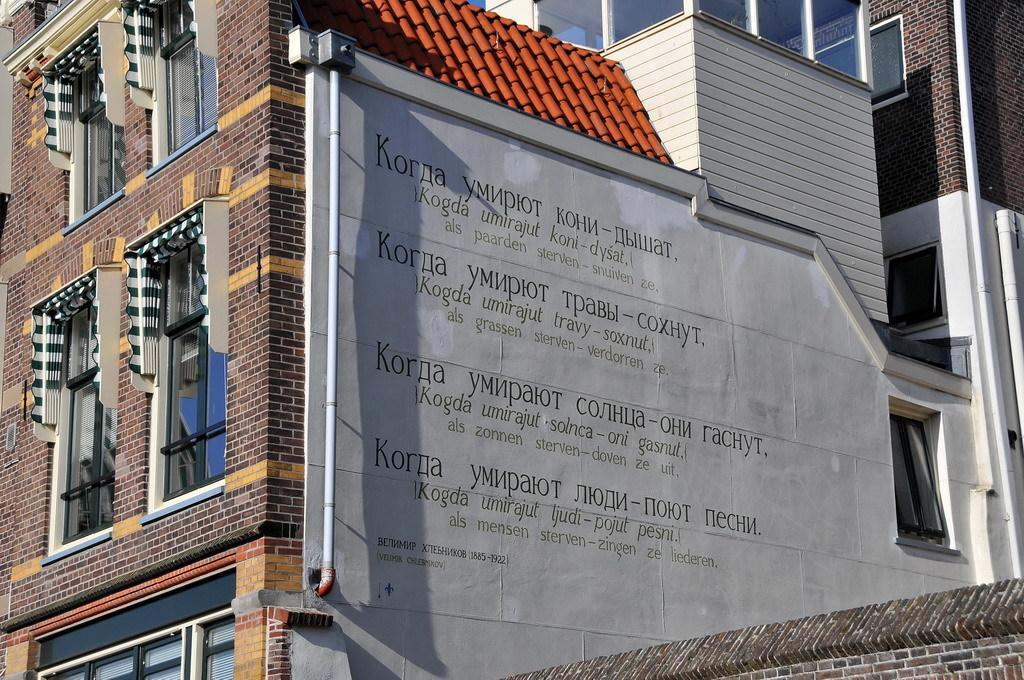What type of structure is present in the image? There is a building in the image. What feature can be seen on the building? The building has windows. What additional object is visible in the image? There is a pipe in the image. What color is the rooftop of the building? The rooftop of the building is red. Can you see a tiger walking on the rooftop of the building in the image? No, there is no tiger or any animal visible in the image. Is there a kettle boiling on the rooftop of the building in the image? No, there is no kettle or any cooking appliance visible in the image. 